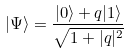<formula> <loc_0><loc_0><loc_500><loc_500>| \Psi \rangle = \frac { | 0 \rangle + q | 1 \rangle } { \sqrt { 1 + | q | ^ { 2 } } }</formula> 